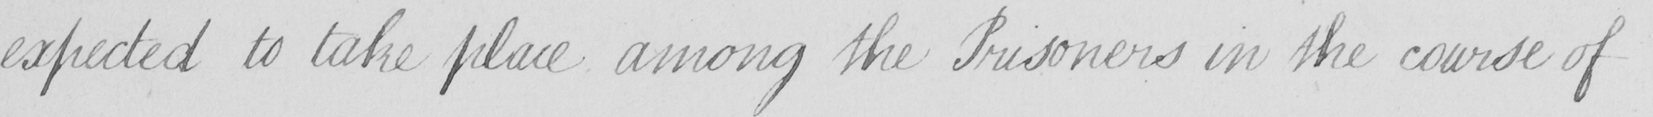Can you tell me what this handwritten text says? expected to take place among the Prisoners in the course of 